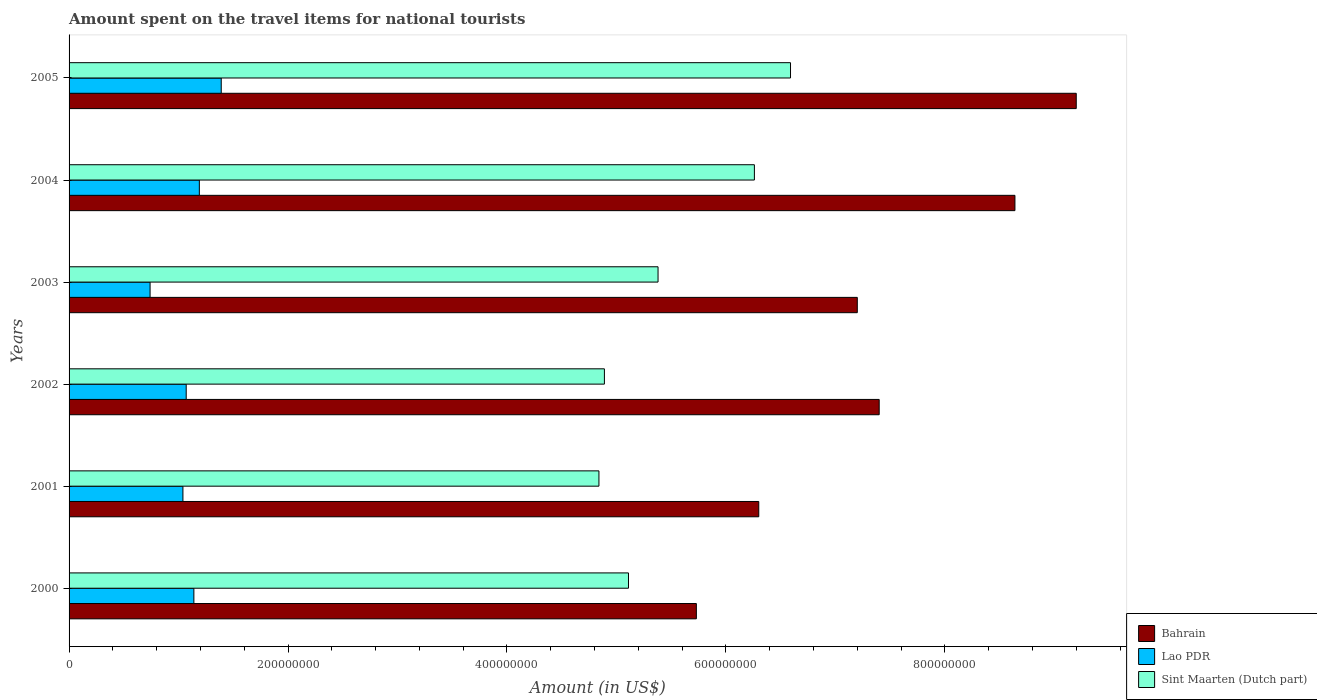Are the number of bars per tick equal to the number of legend labels?
Provide a succinct answer. Yes. How many bars are there on the 3rd tick from the bottom?
Your answer should be compact. 3. What is the label of the 4th group of bars from the top?
Provide a succinct answer. 2002. In how many cases, is the number of bars for a given year not equal to the number of legend labels?
Your answer should be compact. 0. What is the amount spent on the travel items for national tourists in Sint Maarten (Dutch part) in 2001?
Ensure brevity in your answer.  4.84e+08. Across all years, what is the maximum amount spent on the travel items for national tourists in Lao PDR?
Ensure brevity in your answer.  1.39e+08. Across all years, what is the minimum amount spent on the travel items for national tourists in Lao PDR?
Your response must be concise. 7.40e+07. In which year was the amount spent on the travel items for national tourists in Lao PDR minimum?
Provide a short and direct response. 2003. What is the total amount spent on the travel items for national tourists in Lao PDR in the graph?
Give a very brief answer. 6.57e+08. What is the difference between the amount spent on the travel items for national tourists in Sint Maarten (Dutch part) in 2000 and that in 2003?
Provide a succinct answer. -2.70e+07. What is the difference between the amount spent on the travel items for national tourists in Bahrain in 2000 and the amount spent on the travel items for national tourists in Lao PDR in 2002?
Keep it short and to the point. 4.66e+08. What is the average amount spent on the travel items for national tourists in Lao PDR per year?
Make the answer very short. 1.10e+08. In the year 2000, what is the difference between the amount spent on the travel items for national tourists in Sint Maarten (Dutch part) and amount spent on the travel items for national tourists in Bahrain?
Offer a terse response. -6.20e+07. What is the ratio of the amount spent on the travel items for national tourists in Bahrain in 2001 to that in 2002?
Offer a very short reply. 0.85. Is the amount spent on the travel items for national tourists in Bahrain in 2002 less than that in 2005?
Ensure brevity in your answer.  Yes. Is the difference between the amount spent on the travel items for national tourists in Sint Maarten (Dutch part) in 2001 and 2005 greater than the difference between the amount spent on the travel items for national tourists in Bahrain in 2001 and 2005?
Your answer should be very brief. Yes. What is the difference between the highest and the second highest amount spent on the travel items for national tourists in Sint Maarten (Dutch part)?
Make the answer very short. 3.30e+07. What is the difference between the highest and the lowest amount spent on the travel items for national tourists in Sint Maarten (Dutch part)?
Provide a short and direct response. 1.75e+08. What does the 3rd bar from the top in 2002 represents?
Offer a terse response. Bahrain. What does the 1st bar from the bottom in 2000 represents?
Your response must be concise. Bahrain. How many years are there in the graph?
Make the answer very short. 6. Does the graph contain any zero values?
Your answer should be compact. No. Where does the legend appear in the graph?
Offer a very short reply. Bottom right. How many legend labels are there?
Offer a very short reply. 3. What is the title of the graph?
Provide a short and direct response. Amount spent on the travel items for national tourists. What is the label or title of the Y-axis?
Provide a succinct answer. Years. What is the Amount (in US$) of Bahrain in 2000?
Provide a succinct answer. 5.73e+08. What is the Amount (in US$) in Lao PDR in 2000?
Your response must be concise. 1.14e+08. What is the Amount (in US$) of Sint Maarten (Dutch part) in 2000?
Your answer should be compact. 5.11e+08. What is the Amount (in US$) in Bahrain in 2001?
Your answer should be compact. 6.30e+08. What is the Amount (in US$) of Lao PDR in 2001?
Provide a succinct answer. 1.04e+08. What is the Amount (in US$) of Sint Maarten (Dutch part) in 2001?
Provide a succinct answer. 4.84e+08. What is the Amount (in US$) in Bahrain in 2002?
Make the answer very short. 7.40e+08. What is the Amount (in US$) of Lao PDR in 2002?
Keep it short and to the point. 1.07e+08. What is the Amount (in US$) in Sint Maarten (Dutch part) in 2002?
Offer a terse response. 4.89e+08. What is the Amount (in US$) of Bahrain in 2003?
Your response must be concise. 7.20e+08. What is the Amount (in US$) in Lao PDR in 2003?
Provide a succinct answer. 7.40e+07. What is the Amount (in US$) in Sint Maarten (Dutch part) in 2003?
Provide a succinct answer. 5.38e+08. What is the Amount (in US$) of Bahrain in 2004?
Your answer should be very brief. 8.64e+08. What is the Amount (in US$) of Lao PDR in 2004?
Keep it short and to the point. 1.19e+08. What is the Amount (in US$) in Sint Maarten (Dutch part) in 2004?
Your answer should be compact. 6.26e+08. What is the Amount (in US$) in Bahrain in 2005?
Provide a succinct answer. 9.20e+08. What is the Amount (in US$) in Lao PDR in 2005?
Your answer should be very brief. 1.39e+08. What is the Amount (in US$) of Sint Maarten (Dutch part) in 2005?
Your answer should be very brief. 6.59e+08. Across all years, what is the maximum Amount (in US$) of Bahrain?
Give a very brief answer. 9.20e+08. Across all years, what is the maximum Amount (in US$) in Lao PDR?
Your answer should be compact. 1.39e+08. Across all years, what is the maximum Amount (in US$) in Sint Maarten (Dutch part)?
Keep it short and to the point. 6.59e+08. Across all years, what is the minimum Amount (in US$) of Bahrain?
Your answer should be very brief. 5.73e+08. Across all years, what is the minimum Amount (in US$) of Lao PDR?
Ensure brevity in your answer.  7.40e+07. Across all years, what is the minimum Amount (in US$) of Sint Maarten (Dutch part)?
Your answer should be very brief. 4.84e+08. What is the total Amount (in US$) of Bahrain in the graph?
Your answer should be compact. 4.45e+09. What is the total Amount (in US$) of Lao PDR in the graph?
Make the answer very short. 6.57e+08. What is the total Amount (in US$) in Sint Maarten (Dutch part) in the graph?
Your answer should be compact. 3.31e+09. What is the difference between the Amount (in US$) of Bahrain in 2000 and that in 2001?
Your answer should be very brief. -5.70e+07. What is the difference between the Amount (in US$) in Lao PDR in 2000 and that in 2001?
Provide a succinct answer. 1.00e+07. What is the difference between the Amount (in US$) in Sint Maarten (Dutch part) in 2000 and that in 2001?
Make the answer very short. 2.70e+07. What is the difference between the Amount (in US$) in Bahrain in 2000 and that in 2002?
Your answer should be compact. -1.67e+08. What is the difference between the Amount (in US$) in Sint Maarten (Dutch part) in 2000 and that in 2002?
Ensure brevity in your answer.  2.20e+07. What is the difference between the Amount (in US$) in Bahrain in 2000 and that in 2003?
Provide a short and direct response. -1.47e+08. What is the difference between the Amount (in US$) in Lao PDR in 2000 and that in 2003?
Your answer should be very brief. 4.00e+07. What is the difference between the Amount (in US$) of Sint Maarten (Dutch part) in 2000 and that in 2003?
Offer a terse response. -2.70e+07. What is the difference between the Amount (in US$) in Bahrain in 2000 and that in 2004?
Give a very brief answer. -2.91e+08. What is the difference between the Amount (in US$) in Lao PDR in 2000 and that in 2004?
Your response must be concise. -5.00e+06. What is the difference between the Amount (in US$) in Sint Maarten (Dutch part) in 2000 and that in 2004?
Ensure brevity in your answer.  -1.15e+08. What is the difference between the Amount (in US$) in Bahrain in 2000 and that in 2005?
Offer a very short reply. -3.47e+08. What is the difference between the Amount (in US$) in Lao PDR in 2000 and that in 2005?
Ensure brevity in your answer.  -2.50e+07. What is the difference between the Amount (in US$) in Sint Maarten (Dutch part) in 2000 and that in 2005?
Provide a succinct answer. -1.48e+08. What is the difference between the Amount (in US$) in Bahrain in 2001 and that in 2002?
Your answer should be compact. -1.10e+08. What is the difference between the Amount (in US$) of Lao PDR in 2001 and that in 2002?
Provide a succinct answer. -3.00e+06. What is the difference between the Amount (in US$) of Sint Maarten (Dutch part) in 2001 and that in 2002?
Give a very brief answer. -5.00e+06. What is the difference between the Amount (in US$) in Bahrain in 2001 and that in 2003?
Your answer should be compact. -9.00e+07. What is the difference between the Amount (in US$) of Lao PDR in 2001 and that in 2003?
Offer a terse response. 3.00e+07. What is the difference between the Amount (in US$) of Sint Maarten (Dutch part) in 2001 and that in 2003?
Give a very brief answer. -5.40e+07. What is the difference between the Amount (in US$) in Bahrain in 2001 and that in 2004?
Your answer should be very brief. -2.34e+08. What is the difference between the Amount (in US$) of Lao PDR in 2001 and that in 2004?
Your answer should be very brief. -1.50e+07. What is the difference between the Amount (in US$) in Sint Maarten (Dutch part) in 2001 and that in 2004?
Your answer should be compact. -1.42e+08. What is the difference between the Amount (in US$) in Bahrain in 2001 and that in 2005?
Your response must be concise. -2.90e+08. What is the difference between the Amount (in US$) of Lao PDR in 2001 and that in 2005?
Provide a short and direct response. -3.50e+07. What is the difference between the Amount (in US$) of Sint Maarten (Dutch part) in 2001 and that in 2005?
Ensure brevity in your answer.  -1.75e+08. What is the difference between the Amount (in US$) in Bahrain in 2002 and that in 2003?
Provide a short and direct response. 2.00e+07. What is the difference between the Amount (in US$) of Lao PDR in 2002 and that in 2003?
Ensure brevity in your answer.  3.30e+07. What is the difference between the Amount (in US$) in Sint Maarten (Dutch part) in 2002 and that in 2003?
Your answer should be very brief. -4.90e+07. What is the difference between the Amount (in US$) in Bahrain in 2002 and that in 2004?
Provide a short and direct response. -1.24e+08. What is the difference between the Amount (in US$) in Lao PDR in 2002 and that in 2004?
Provide a short and direct response. -1.20e+07. What is the difference between the Amount (in US$) in Sint Maarten (Dutch part) in 2002 and that in 2004?
Offer a terse response. -1.37e+08. What is the difference between the Amount (in US$) in Bahrain in 2002 and that in 2005?
Your answer should be compact. -1.80e+08. What is the difference between the Amount (in US$) of Lao PDR in 2002 and that in 2005?
Your response must be concise. -3.20e+07. What is the difference between the Amount (in US$) in Sint Maarten (Dutch part) in 2002 and that in 2005?
Your answer should be compact. -1.70e+08. What is the difference between the Amount (in US$) of Bahrain in 2003 and that in 2004?
Your response must be concise. -1.44e+08. What is the difference between the Amount (in US$) in Lao PDR in 2003 and that in 2004?
Give a very brief answer. -4.50e+07. What is the difference between the Amount (in US$) in Sint Maarten (Dutch part) in 2003 and that in 2004?
Ensure brevity in your answer.  -8.80e+07. What is the difference between the Amount (in US$) in Bahrain in 2003 and that in 2005?
Ensure brevity in your answer.  -2.00e+08. What is the difference between the Amount (in US$) of Lao PDR in 2003 and that in 2005?
Keep it short and to the point. -6.50e+07. What is the difference between the Amount (in US$) in Sint Maarten (Dutch part) in 2003 and that in 2005?
Provide a short and direct response. -1.21e+08. What is the difference between the Amount (in US$) of Bahrain in 2004 and that in 2005?
Offer a terse response. -5.60e+07. What is the difference between the Amount (in US$) of Lao PDR in 2004 and that in 2005?
Give a very brief answer. -2.00e+07. What is the difference between the Amount (in US$) in Sint Maarten (Dutch part) in 2004 and that in 2005?
Your answer should be compact. -3.30e+07. What is the difference between the Amount (in US$) of Bahrain in 2000 and the Amount (in US$) of Lao PDR in 2001?
Provide a short and direct response. 4.69e+08. What is the difference between the Amount (in US$) of Bahrain in 2000 and the Amount (in US$) of Sint Maarten (Dutch part) in 2001?
Give a very brief answer. 8.90e+07. What is the difference between the Amount (in US$) of Lao PDR in 2000 and the Amount (in US$) of Sint Maarten (Dutch part) in 2001?
Make the answer very short. -3.70e+08. What is the difference between the Amount (in US$) in Bahrain in 2000 and the Amount (in US$) in Lao PDR in 2002?
Provide a short and direct response. 4.66e+08. What is the difference between the Amount (in US$) of Bahrain in 2000 and the Amount (in US$) of Sint Maarten (Dutch part) in 2002?
Keep it short and to the point. 8.40e+07. What is the difference between the Amount (in US$) of Lao PDR in 2000 and the Amount (in US$) of Sint Maarten (Dutch part) in 2002?
Offer a terse response. -3.75e+08. What is the difference between the Amount (in US$) in Bahrain in 2000 and the Amount (in US$) in Lao PDR in 2003?
Provide a succinct answer. 4.99e+08. What is the difference between the Amount (in US$) in Bahrain in 2000 and the Amount (in US$) in Sint Maarten (Dutch part) in 2003?
Give a very brief answer. 3.50e+07. What is the difference between the Amount (in US$) of Lao PDR in 2000 and the Amount (in US$) of Sint Maarten (Dutch part) in 2003?
Keep it short and to the point. -4.24e+08. What is the difference between the Amount (in US$) in Bahrain in 2000 and the Amount (in US$) in Lao PDR in 2004?
Your response must be concise. 4.54e+08. What is the difference between the Amount (in US$) of Bahrain in 2000 and the Amount (in US$) of Sint Maarten (Dutch part) in 2004?
Provide a short and direct response. -5.30e+07. What is the difference between the Amount (in US$) of Lao PDR in 2000 and the Amount (in US$) of Sint Maarten (Dutch part) in 2004?
Ensure brevity in your answer.  -5.12e+08. What is the difference between the Amount (in US$) of Bahrain in 2000 and the Amount (in US$) of Lao PDR in 2005?
Your answer should be compact. 4.34e+08. What is the difference between the Amount (in US$) of Bahrain in 2000 and the Amount (in US$) of Sint Maarten (Dutch part) in 2005?
Keep it short and to the point. -8.60e+07. What is the difference between the Amount (in US$) in Lao PDR in 2000 and the Amount (in US$) in Sint Maarten (Dutch part) in 2005?
Offer a terse response. -5.45e+08. What is the difference between the Amount (in US$) in Bahrain in 2001 and the Amount (in US$) in Lao PDR in 2002?
Keep it short and to the point. 5.23e+08. What is the difference between the Amount (in US$) of Bahrain in 2001 and the Amount (in US$) of Sint Maarten (Dutch part) in 2002?
Provide a succinct answer. 1.41e+08. What is the difference between the Amount (in US$) in Lao PDR in 2001 and the Amount (in US$) in Sint Maarten (Dutch part) in 2002?
Offer a very short reply. -3.85e+08. What is the difference between the Amount (in US$) of Bahrain in 2001 and the Amount (in US$) of Lao PDR in 2003?
Your response must be concise. 5.56e+08. What is the difference between the Amount (in US$) in Bahrain in 2001 and the Amount (in US$) in Sint Maarten (Dutch part) in 2003?
Make the answer very short. 9.20e+07. What is the difference between the Amount (in US$) in Lao PDR in 2001 and the Amount (in US$) in Sint Maarten (Dutch part) in 2003?
Provide a short and direct response. -4.34e+08. What is the difference between the Amount (in US$) in Bahrain in 2001 and the Amount (in US$) in Lao PDR in 2004?
Offer a terse response. 5.11e+08. What is the difference between the Amount (in US$) in Lao PDR in 2001 and the Amount (in US$) in Sint Maarten (Dutch part) in 2004?
Give a very brief answer. -5.22e+08. What is the difference between the Amount (in US$) of Bahrain in 2001 and the Amount (in US$) of Lao PDR in 2005?
Make the answer very short. 4.91e+08. What is the difference between the Amount (in US$) of Bahrain in 2001 and the Amount (in US$) of Sint Maarten (Dutch part) in 2005?
Keep it short and to the point. -2.90e+07. What is the difference between the Amount (in US$) in Lao PDR in 2001 and the Amount (in US$) in Sint Maarten (Dutch part) in 2005?
Offer a very short reply. -5.55e+08. What is the difference between the Amount (in US$) in Bahrain in 2002 and the Amount (in US$) in Lao PDR in 2003?
Make the answer very short. 6.66e+08. What is the difference between the Amount (in US$) of Bahrain in 2002 and the Amount (in US$) of Sint Maarten (Dutch part) in 2003?
Offer a very short reply. 2.02e+08. What is the difference between the Amount (in US$) in Lao PDR in 2002 and the Amount (in US$) in Sint Maarten (Dutch part) in 2003?
Your response must be concise. -4.31e+08. What is the difference between the Amount (in US$) of Bahrain in 2002 and the Amount (in US$) of Lao PDR in 2004?
Provide a succinct answer. 6.21e+08. What is the difference between the Amount (in US$) in Bahrain in 2002 and the Amount (in US$) in Sint Maarten (Dutch part) in 2004?
Ensure brevity in your answer.  1.14e+08. What is the difference between the Amount (in US$) of Lao PDR in 2002 and the Amount (in US$) of Sint Maarten (Dutch part) in 2004?
Your answer should be compact. -5.19e+08. What is the difference between the Amount (in US$) of Bahrain in 2002 and the Amount (in US$) of Lao PDR in 2005?
Your answer should be very brief. 6.01e+08. What is the difference between the Amount (in US$) of Bahrain in 2002 and the Amount (in US$) of Sint Maarten (Dutch part) in 2005?
Keep it short and to the point. 8.10e+07. What is the difference between the Amount (in US$) of Lao PDR in 2002 and the Amount (in US$) of Sint Maarten (Dutch part) in 2005?
Provide a succinct answer. -5.52e+08. What is the difference between the Amount (in US$) of Bahrain in 2003 and the Amount (in US$) of Lao PDR in 2004?
Provide a short and direct response. 6.01e+08. What is the difference between the Amount (in US$) in Bahrain in 2003 and the Amount (in US$) in Sint Maarten (Dutch part) in 2004?
Give a very brief answer. 9.40e+07. What is the difference between the Amount (in US$) of Lao PDR in 2003 and the Amount (in US$) of Sint Maarten (Dutch part) in 2004?
Your answer should be very brief. -5.52e+08. What is the difference between the Amount (in US$) in Bahrain in 2003 and the Amount (in US$) in Lao PDR in 2005?
Offer a terse response. 5.81e+08. What is the difference between the Amount (in US$) in Bahrain in 2003 and the Amount (in US$) in Sint Maarten (Dutch part) in 2005?
Offer a very short reply. 6.10e+07. What is the difference between the Amount (in US$) in Lao PDR in 2003 and the Amount (in US$) in Sint Maarten (Dutch part) in 2005?
Provide a succinct answer. -5.85e+08. What is the difference between the Amount (in US$) in Bahrain in 2004 and the Amount (in US$) in Lao PDR in 2005?
Your answer should be compact. 7.25e+08. What is the difference between the Amount (in US$) in Bahrain in 2004 and the Amount (in US$) in Sint Maarten (Dutch part) in 2005?
Ensure brevity in your answer.  2.05e+08. What is the difference between the Amount (in US$) in Lao PDR in 2004 and the Amount (in US$) in Sint Maarten (Dutch part) in 2005?
Provide a succinct answer. -5.40e+08. What is the average Amount (in US$) of Bahrain per year?
Provide a short and direct response. 7.41e+08. What is the average Amount (in US$) of Lao PDR per year?
Keep it short and to the point. 1.10e+08. What is the average Amount (in US$) of Sint Maarten (Dutch part) per year?
Provide a short and direct response. 5.51e+08. In the year 2000, what is the difference between the Amount (in US$) of Bahrain and Amount (in US$) of Lao PDR?
Offer a terse response. 4.59e+08. In the year 2000, what is the difference between the Amount (in US$) in Bahrain and Amount (in US$) in Sint Maarten (Dutch part)?
Your answer should be very brief. 6.20e+07. In the year 2000, what is the difference between the Amount (in US$) in Lao PDR and Amount (in US$) in Sint Maarten (Dutch part)?
Provide a short and direct response. -3.97e+08. In the year 2001, what is the difference between the Amount (in US$) of Bahrain and Amount (in US$) of Lao PDR?
Give a very brief answer. 5.26e+08. In the year 2001, what is the difference between the Amount (in US$) in Bahrain and Amount (in US$) in Sint Maarten (Dutch part)?
Offer a terse response. 1.46e+08. In the year 2001, what is the difference between the Amount (in US$) in Lao PDR and Amount (in US$) in Sint Maarten (Dutch part)?
Offer a terse response. -3.80e+08. In the year 2002, what is the difference between the Amount (in US$) in Bahrain and Amount (in US$) in Lao PDR?
Provide a succinct answer. 6.33e+08. In the year 2002, what is the difference between the Amount (in US$) in Bahrain and Amount (in US$) in Sint Maarten (Dutch part)?
Your response must be concise. 2.51e+08. In the year 2002, what is the difference between the Amount (in US$) in Lao PDR and Amount (in US$) in Sint Maarten (Dutch part)?
Ensure brevity in your answer.  -3.82e+08. In the year 2003, what is the difference between the Amount (in US$) of Bahrain and Amount (in US$) of Lao PDR?
Your answer should be very brief. 6.46e+08. In the year 2003, what is the difference between the Amount (in US$) in Bahrain and Amount (in US$) in Sint Maarten (Dutch part)?
Offer a terse response. 1.82e+08. In the year 2003, what is the difference between the Amount (in US$) in Lao PDR and Amount (in US$) in Sint Maarten (Dutch part)?
Make the answer very short. -4.64e+08. In the year 2004, what is the difference between the Amount (in US$) in Bahrain and Amount (in US$) in Lao PDR?
Your answer should be compact. 7.45e+08. In the year 2004, what is the difference between the Amount (in US$) in Bahrain and Amount (in US$) in Sint Maarten (Dutch part)?
Offer a very short reply. 2.38e+08. In the year 2004, what is the difference between the Amount (in US$) of Lao PDR and Amount (in US$) of Sint Maarten (Dutch part)?
Your response must be concise. -5.07e+08. In the year 2005, what is the difference between the Amount (in US$) of Bahrain and Amount (in US$) of Lao PDR?
Keep it short and to the point. 7.81e+08. In the year 2005, what is the difference between the Amount (in US$) of Bahrain and Amount (in US$) of Sint Maarten (Dutch part)?
Offer a very short reply. 2.61e+08. In the year 2005, what is the difference between the Amount (in US$) of Lao PDR and Amount (in US$) of Sint Maarten (Dutch part)?
Your response must be concise. -5.20e+08. What is the ratio of the Amount (in US$) in Bahrain in 2000 to that in 2001?
Offer a terse response. 0.91. What is the ratio of the Amount (in US$) in Lao PDR in 2000 to that in 2001?
Give a very brief answer. 1.1. What is the ratio of the Amount (in US$) in Sint Maarten (Dutch part) in 2000 to that in 2001?
Your answer should be very brief. 1.06. What is the ratio of the Amount (in US$) of Bahrain in 2000 to that in 2002?
Offer a very short reply. 0.77. What is the ratio of the Amount (in US$) of Lao PDR in 2000 to that in 2002?
Your answer should be compact. 1.07. What is the ratio of the Amount (in US$) of Sint Maarten (Dutch part) in 2000 to that in 2002?
Your answer should be very brief. 1.04. What is the ratio of the Amount (in US$) in Bahrain in 2000 to that in 2003?
Your answer should be compact. 0.8. What is the ratio of the Amount (in US$) in Lao PDR in 2000 to that in 2003?
Make the answer very short. 1.54. What is the ratio of the Amount (in US$) of Sint Maarten (Dutch part) in 2000 to that in 2003?
Make the answer very short. 0.95. What is the ratio of the Amount (in US$) of Bahrain in 2000 to that in 2004?
Keep it short and to the point. 0.66. What is the ratio of the Amount (in US$) in Lao PDR in 2000 to that in 2004?
Your answer should be very brief. 0.96. What is the ratio of the Amount (in US$) of Sint Maarten (Dutch part) in 2000 to that in 2004?
Provide a short and direct response. 0.82. What is the ratio of the Amount (in US$) of Bahrain in 2000 to that in 2005?
Offer a terse response. 0.62. What is the ratio of the Amount (in US$) of Lao PDR in 2000 to that in 2005?
Ensure brevity in your answer.  0.82. What is the ratio of the Amount (in US$) of Sint Maarten (Dutch part) in 2000 to that in 2005?
Offer a very short reply. 0.78. What is the ratio of the Amount (in US$) in Bahrain in 2001 to that in 2002?
Your answer should be compact. 0.85. What is the ratio of the Amount (in US$) in Lao PDR in 2001 to that in 2002?
Offer a very short reply. 0.97. What is the ratio of the Amount (in US$) in Sint Maarten (Dutch part) in 2001 to that in 2002?
Your answer should be very brief. 0.99. What is the ratio of the Amount (in US$) in Lao PDR in 2001 to that in 2003?
Give a very brief answer. 1.41. What is the ratio of the Amount (in US$) in Sint Maarten (Dutch part) in 2001 to that in 2003?
Ensure brevity in your answer.  0.9. What is the ratio of the Amount (in US$) in Bahrain in 2001 to that in 2004?
Provide a succinct answer. 0.73. What is the ratio of the Amount (in US$) in Lao PDR in 2001 to that in 2004?
Provide a succinct answer. 0.87. What is the ratio of the Amount (in US$) in Sint Maarten (Dutch part) in 2001 to that in 2004?
Your answer should be very brief. 0.77. What is the ratio of the Amount (in US$) in Bahrain in 2001 to that in 2005?
Offer a terse response. 0.68. What is the ratio of the Amount (in US$) of Lao PDR in 2001 to that in 2005?
Ensure brevity in your answer.  0.75. What is the ratio of the Amount (in US$) in Sint Maarten (Dutch part) in 2001 to that in 2005?
Keep it short and to the point. 0.73. What is the ratio of the Amount (in US$) in Bahrain in 2002 to that in 2003?
Make the answer very short. 1.03. What is the ratio of the Amount (in US$) in Lao PDR in 2002 to that in 2003?
Your response must be concise. 1.45. What is the ratio of the Amount (in US$) in Sint Maarten (Dutch part) in 2002 to that in 2003?
Provide a short and direct response. 0.91. What is the ratio of the Amount (in US$) in Bahrain in 2002 to that in 2004?
Offer a terse response. 0.86. What is the ratio of the Amount (in US$) in Lao PDR in 2002 to that in 2004?
Provide a short and direct response. 0.9. What is the ratio of the Amount (in US$) in Sint Maarten (Dutch part) in 2002 to that in 2004?
Offer a very short reply. 0.78. What is the ratio of the Amount (in US$) in Bahrain in 2002 to that in 2005?
Make the answer very short. 0.8. What is the ratio of the Amount (in US$) of Lao PDR in 2002 to that in 2005?
Ensure brevity in your answer.  0.77. What is the ratio of the Amount (in US$) in Sint Maarten (Dutch part) in 2002 to that in 2005?
Your answer should be compact. 0.74. What is the ratio of the Amount (in US$) of Bahrain in 2003 to that in 2004?
Ensure brevity in your answer.  0.83. What is the ratio of the Amount (in US$) in Lao PDR in 2003 to that in 2004?
Keep it short and to the point. 0.62. What is the ratio of the Amount (in US$) of Sint Maarten (Dutch part) in 2003 to that in 2004?
Keep it short and to the point. 0.86. What is the ratio of the Amount (in US$) in Bahrain in 2003 to that in 2005?
Make the answer very short. 0.78. What is the ratio of the Amount (in US$) of Lao PDR in 2003 to that in 2005?
Provide a short and direct response. 0.53. What is the ratio of the Amount (in US$) in Sint Maarten (Dutch part) in 2003 to that in 2005?
Your answer should be very brief. 0.82. What is the ratio of the Amount (in US$) of Bahrain in 2004 to that in 2005?
Make the answer very short. 0.94. What is the ratio of the Amount (in US$) of Lao PDR in 2004 to that in 2005?
Offer a very short reply. 0.86. What is the ratio of the Amount (in US$) of Sint Maarten (Dutch part) in 2004 to that in 2005?
Your answer should be very brief. 0.95. What is the difference between the highest and the second highest Amount (in US$) of Bahrain?
Your answer should be compact. 5.60e+07. What is the difference between the highest and the second highest Amount (in US$) in Lao PDR?
Your answer should be very brief. 2.00e+07. What is the difference between the highest and the second highest Amount (in US$) of Sint Maarten (Dutch part)?
Give a very brief answer. 3.30e+07. What is the difference between the highest and the lowest Amount (in US$) in Bahrain?
Keep it short and to the point. 3.47e+08. What is the difference between the highest and the lowest Amount (in US$) of Lao PDR?
Give a very brief answer. 6.50e+07. What is the difference between the highest and the lowest Amount (in US$) of Sint Maarten (Dutch part)?
Provide a short and direct response. 1.75e+08. 